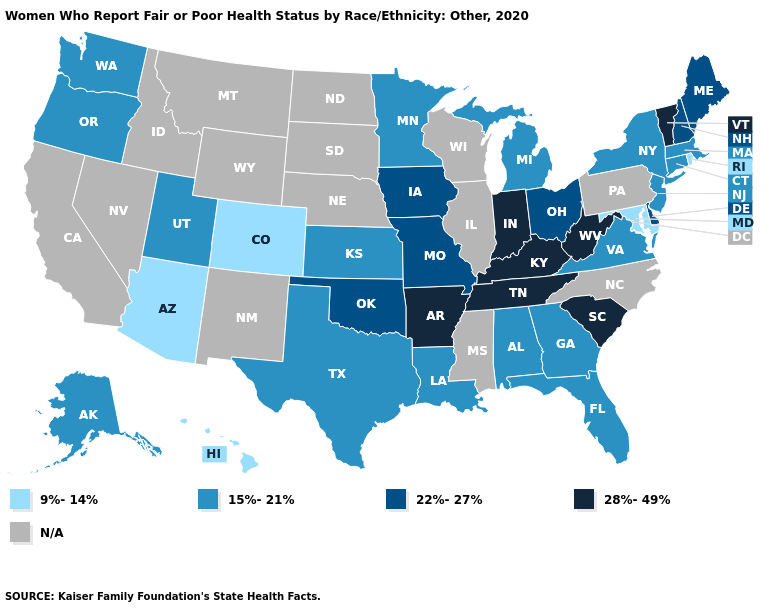What is the value of New Jersey?
Keep it brief. 15%-21%. What is the lowest value in the USA?
Be succinct. 9%-14%. Among the states that border South Carolina , which have the lowest value?
Be succinct. Georgia. Does Delaware have the lowest value in the South?
Concise answer only. No. Name the states that have a value in the range 9%-14%?
Concise answer only. Arizona, Colorado, Hawaii, Maryland, Rhode Island. What is the lowest value in the West?
Quick response, please. 9%-14%. What is the highest value in the West ?
Short answer required. 15%-21%. What is the lowest value in the USA?
Be succinct. 9%-14%. Name the states that have a value in the range N/A?
Short answer required. California, Idaho, Illinois, Mississippi, Montana, Nebraska, Nevada, New Mexico, North Carolina, North Dakota, Pennsylvania, South Dakota, Wisconsin, Wyoming. Does Oregon have the lowest value in the USA?
Keep it brief. No. Name the states that have a value in the range 9%-14%?
Be succinct. Arizona, Colorado, Hawaii, Maryland, Rhode Island. Name the states that have a value in the range 9%-14%?
Concise answer only. Arizona, Colorado, Hawaii, Maryland, Rhode Island. Does Rhode Island have the lowest value in the USA?
Write a very short answer. Yes. What is the value of Nevada?
Answer briefly. N/A. 